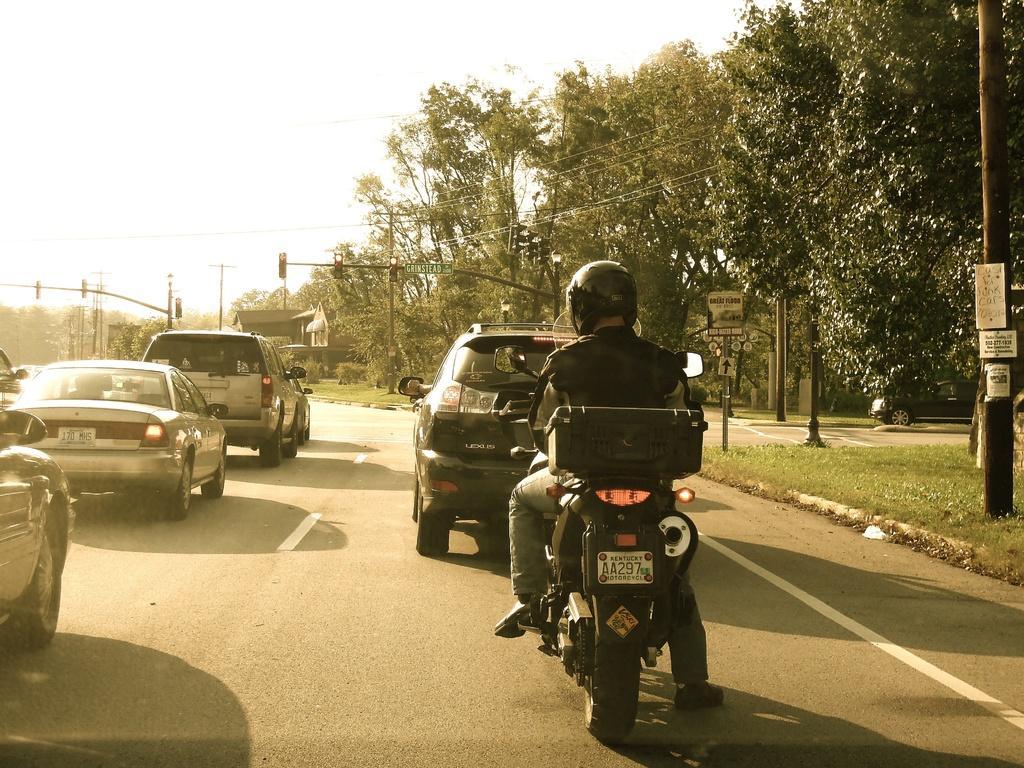In one or two sentences, can you explain what this image depicts? In this image we can see a bike on which a person is sitting and cars on the road. In the background we can see traffic signals and trees. 